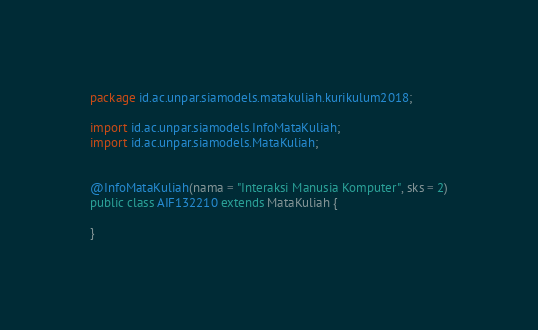<code> <loc_0><loc_0><loc_500><loc_500><_Java_>package id.ac.unpar.siamodels.matakuliah.kurikulum2018;

import id.ac.unpar.siamodels.InfoMataKuliah;
import id.ac.unpar.siamodels.MataKuliah;


@InfoMataKuliah(nama = "Interaksi Manusia Komputer", sks = 2)
public class AIF132210 extends MataKuliah {

}
</code> 